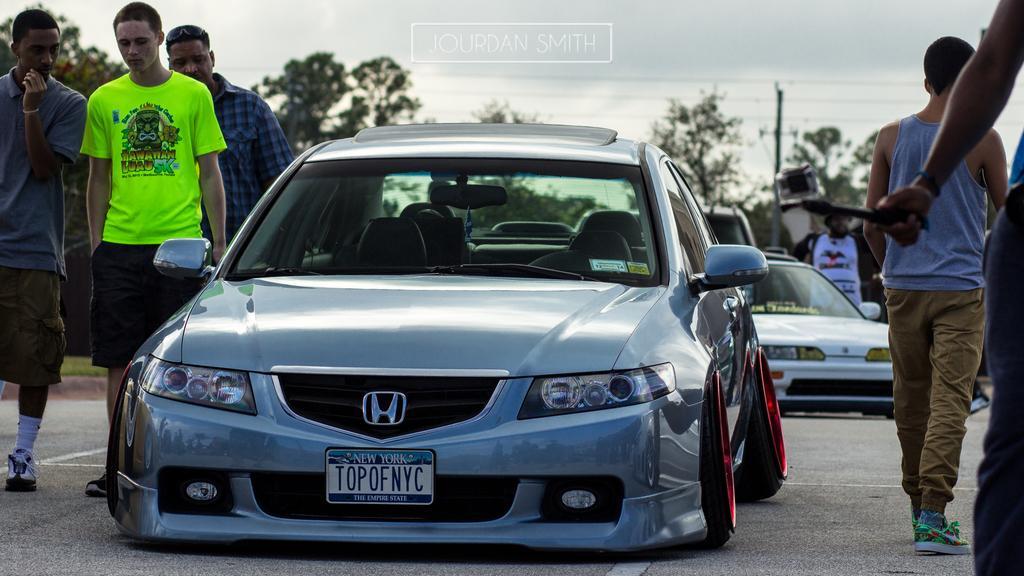Describe this image in one or two sentences. In the center of the image we can see the cars. On the left and right side of the image we can see some persons are standing. On the right side of the image we can see a person is standing and holding an object. In the background of the image we can see the trees, pole. At the top of the image we can see the text and sky. At the bottom of the image we can see the road. 